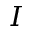Convert formula to latex. <formula><loc_0><loc_0><loc_500><loc_500>I</formula> 